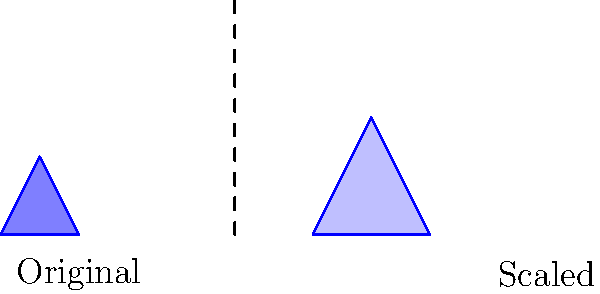A water droplet is represented by a simple triangle-like shape. If this shape is scaled up by a factor of 3, how many times larger will the surface area of the new shape be compared to the original? To solve this problem, let's follow these steps:

1) When a two-dimensional shape is scaled by a factor $k$, its linear dimensions (length and width) are multiplied by $k$.

2) The area of a two-dimensional shape is proportional to the square of its linear dimensions.

3) In this case, the scaling factor $k = 3$.

4) Therefore, the new area will be $k^2 = 3^2 = 9$ times the original area.

5) We can express this mathematically as:

   $A_{new} = k^2 \cdot A_{original}$

   Where $A_{new}$ is the new area and $A_{original}$ is the original area.

6) This means that regardless of the original size or shape of the water droplet, as long as it's a two-dimensional representation, scaling it up by a factor of 3 will always result in an area 9 times larger than the original.

This concept is crucial for understanding how contaminants in water can become more concentrated or diluted, which is relevant to protecting children from waterborne illnesses.
Answer: 9 times larger 